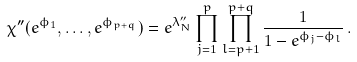<formula> <loc_0><loc_0><loc_500><loc_500>\chi ^ { \prime \prime } ( e ^ { \phi _ { 1 } } , \dots , e ^ { \phi _ { p + q } } ) = e ^ { \lambda _ { N } ^ { \prime \prime } } \prod _ { j = 1 } ^ { p } \prod _ { l = p + 1 } ^ { p + q } \frac { 1 } { 1 - e ^ { \phi _ { j } - \phi _ { l } } } \, .</formula> 